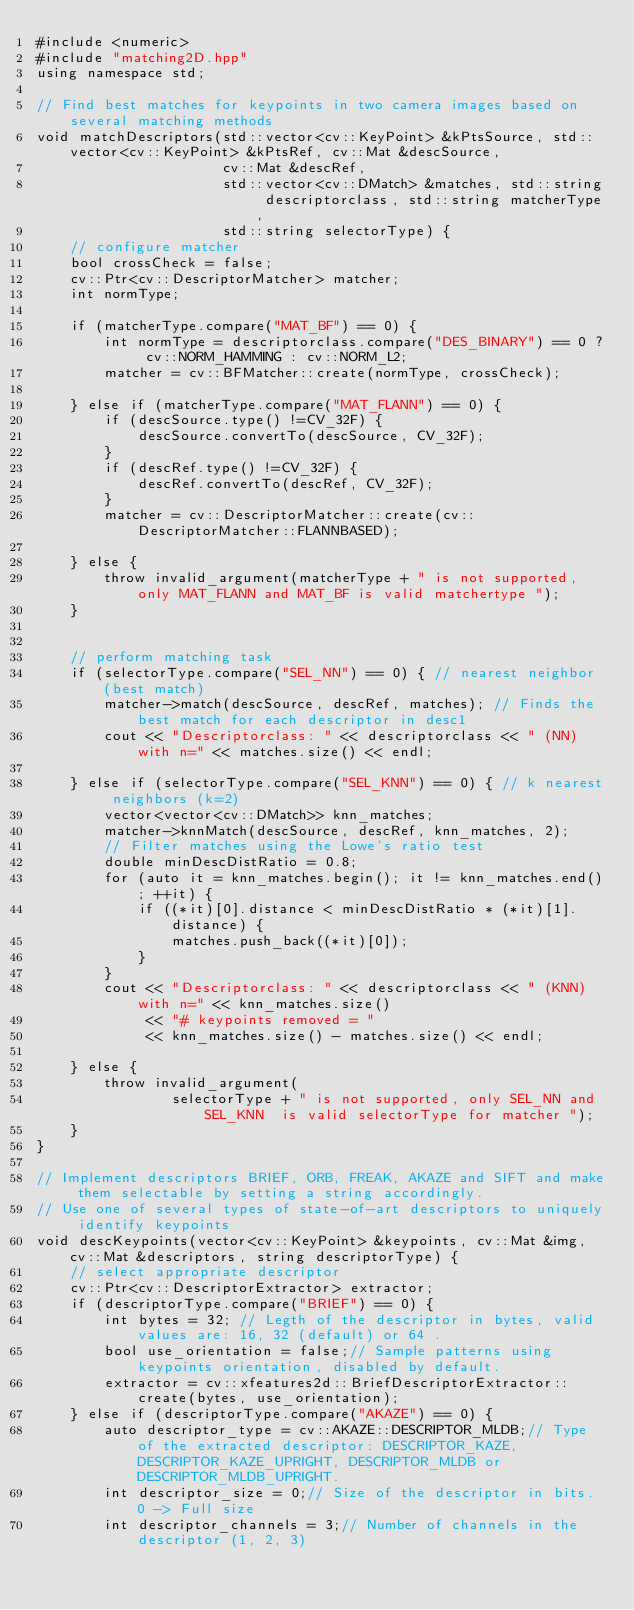<code> <loc_0><loc_0><loc_500><loc_500><_C++_>#include <numeric>
#include "matching2D.hpp"
using namespace std;

// Find best matches for keypoints in two camera images based on several matching methods
void matchDescriptors(std::vector<cv::KeyPoint> &kPtsSource, std::vector<cv::KeyPoint> &kPtsRef, cv::Mat &descSource,
                      cv::Mat &descRef,
                      std::vector<cv::DMatch> &matches, std::string descriptorclass, std::string matcherType,
                      std::string selectorType) {
    // configure matcher
    bool crossCheck = false;
    cv::Ptr<cv::DescriptorMatcher> matcher;
    int normType;

    if (matcherType.compare("MAT_BF") == 0) {
        int normType = descriptorclass.compare("DES_BINARY") == 0 ? cv::NORM_HAMMING : cv::NORM_L2;
        matcher = cv::BFMatcher::create(normType, crossCheck);

    } else if (matcherType.compare("MAT_FLANN") == 0) {
        if (descSource.type() !=CV_32F) {
            descSource.convertTo(descSource, CV_32F);
        }
        if (descRef.type() !=CV_32F) {
            descRef.convertTo(descRef, CV_32F);
        }
        matcher = cv::DescriptorMatcher::create(cv::DescriptorMatcher::FLANNBASED);

    } else {
        throw invalid_argument(matcherType + " is not supported, only MAT_FLANN and MAT_BF is valid matchertype ");
    }


    // perform matching task
    if (selectorType.compare("SEL_NN") == 0) { // nearest neighbor (best match)
        matcher->match(descSource, descRef, matches); // Finds the best match for each descriptor in desc1
        cout << "Descriptorclass: " << descriptorclass << " (NN) with n=" << matches.size() << endl;

    } else if (selectorType.compare("SEL_KNN") == 0) { // k nearest neighbors (k=2)
        vector<vector<cv::DMatch>> knn_matches;
        matcher->knnMatch(descSource, descRef, knn_matches, 2);
        // Filter matches using the Lowe's ratio test
        double minDescDistRatio = 0.8;
        for (auto it = knn_matches.begin(); it != knn_matches.end(); ++it) {
            if ((*it)[0].distance < minDescDistRatio * (*it)[1].distance) {
                matches.push_back((*it)[0]);
            }
        }
        cout << "Descriptorclass: " << descriptorclass << " (KNN) with n=" << knn_matches.size()
             << "# keypoints removed = "
             << knn_matches.size() - matches.size() << endl;

    } else {
        throw invalid_argument(
                selectorType + " is not supported, only SEL_NN and SEL_KNN  is valid selectorType for matcher ");
    }
}

// Implement descriptors BRIEF, ORB, FREAK, AKAZE and SIFT and make them selectable by setting a string accordingly.
// Use one of several types of state-of-art descriptors to uniquely identify keypoints
void descKeypoints(vector<cv::KeyPoint> &keypoints, cv::Mat &img, cv::Mat &descriptors, string descriptorType) {
    // select appropriate descriptor
    cv::Ptr<cv::DescriptorExtractor> extractor;
    if (descriptorType.compare("BRIEF") == 0) {
        int bytes = 32; // Legth of the descriptor in bytes, valid values are: 16, 32 (default) or 64 .
        bool use_orientation = false;// Sample patterns using keypoints orientation, disabled by default.
        extractor = cv::xfeatures2d::BriefDescriptorExtractor::create(bytes, use_orientation);
    } else if (descriptorType.compare("AKAZE") == 0) {
        auto descriptor_type = cv::AKAZE::DESCRIPTOR_MLDB;// Type of the extracted descriptor: DESCRIPTOR_KAZE, DESCRIPTOR_KAZE_UPRIGHT, DESCRIPTOR_MLDB or DESCRIPTOR_MLDB_UPRIGHT.
        int descriptor_size = 0;// Size of the descriptor in bits. 0 -> Full size
        int descriptor_channels = 3;// Number of channels in the descriptor (1, 2, 3)</code> 